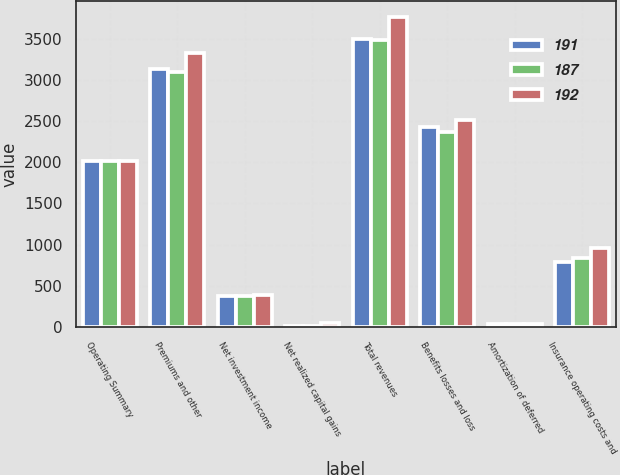<chart> <loc_0><loc_0><loc_500><loc_500><stacked_bar_chart><ecel><fcel>Operating Summary<fcel>Premiums and other<fcel>Net investment income<fcel>Net realized capital gains<fcel>Total revenues<fcel>Benefits losses and loss<fcel>Amortization of deferred<fcel>Insurance operating costs and<nl><fcel>191<fcel>2015<fcel>3136<fcel>371<fcel>11<fcel>3496<fcel>2427<fcel>31<fcel>788<nl><fcel>187<fcel>2014<fcel>3095<fcel>374<fcel>15<fcel>3484<fcel>2362<fcel>32<fcel>836<nl><fcel>192<fcel>2013<fcel>3330<fcel>390<fcel>50<fcel>3770<fcel>2518<fcel>33<fcel>964<nl></chart> 